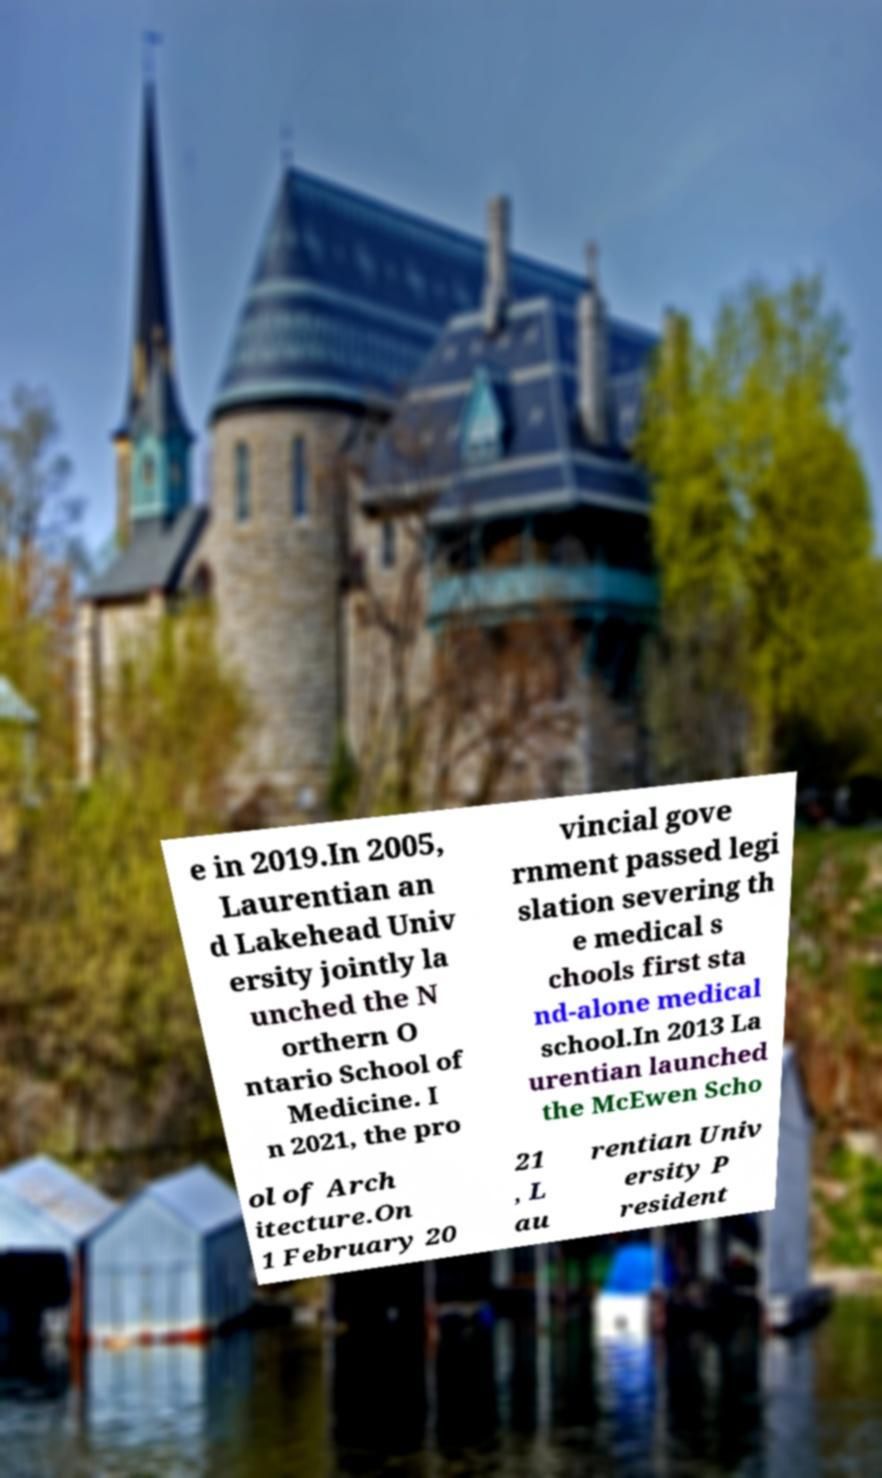Could you assist in decoding the text presented in this image and type it out clearly? e in 2019.In 2005, Laurentian an d Lakehead Univ ersity jointly la unched the N orthern O ntario School of Medicine. I n 2021, the pro vincial gove rnment passed legi slation severing th e medical s chools first sta nd-alone medical school.In 2013 La urentian launched the McEwen Scho ol of Arch itecture.On 1 February 20 21 , L au rentian Univ ersity P resident 